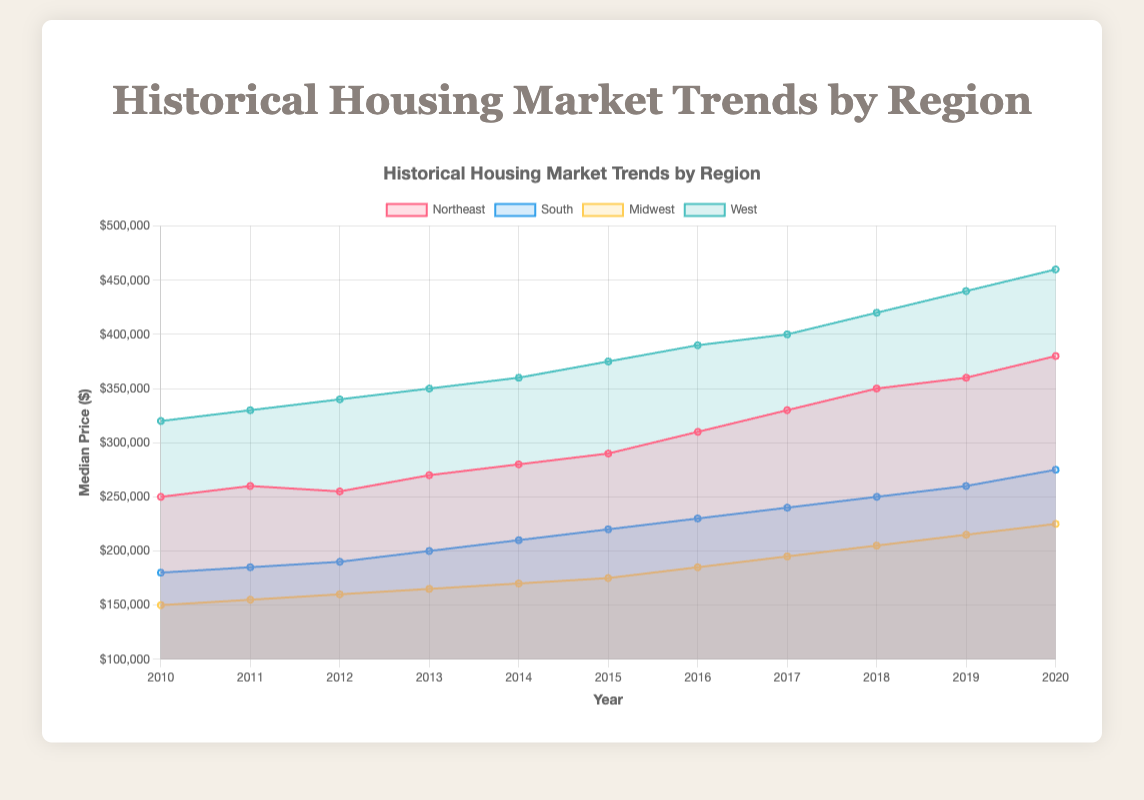What's the title of the chart? The title is displayed at the top of the chart, indicating the overall topic it covers. It reads "Historical Housing Market Trends by Region".
Answer: Historical Housing Market Trends by Region Which region had the highest median price in 2020? By looking at the data points for 2020 on the chart, the West region shows the highest median price of $460,000.
Answer: West How did the median price change in the South from 2010 to 2020? To find this, note the median price in the South was $180,000 in 2010 and $275,000 in 2020, then calculate the difference: $275,000 - $180,000 = $95,000.
Answer: Increased by $95,000 Between which years did the Northeast region see the largest annual price increase? Observe each year's increment for the Northeast region; the largest jump is between 2012 and 2013, from $255,000 to $270,000, an increase of $15,000.
Answer: Between 2012 and 2013 What is the color used to represent the Midwest region? The Midwest region is represented by the color associated with its dataset, which in this case is a yellow-like color (third color in the sequence).
Answer: Yellow Which regions show a continuous year-on-year increase from 2010 to 2020? Examining each region, the South and West regions both show a continuous increase in median price every year from 2010 to 2020.
Answer: South and West What trend can be observed in the housing market of the West region from 2010 to 2020? The trend for the West region shows a consistent year-on-year increase in the median price, culminating in the highest value among all regions by 2020.
Answer: Consistent increase How does the median price in the Midwest compare to the Northeast in 2020? In 2020, the median price in the Midwest is $225,000, while in the Northeast it is $380,000. Therefore, the Northeast has a higher median price.
Answer: Northeast has a higher median price Could you describe the trend for the Northeast region between 2010 and 2015? The Northeast region initially saw a slight fluctuation, but overall, the median prices increased steadily from 2010 ($250,000) to 2015 ($290,000).
Answer: Overall increase 